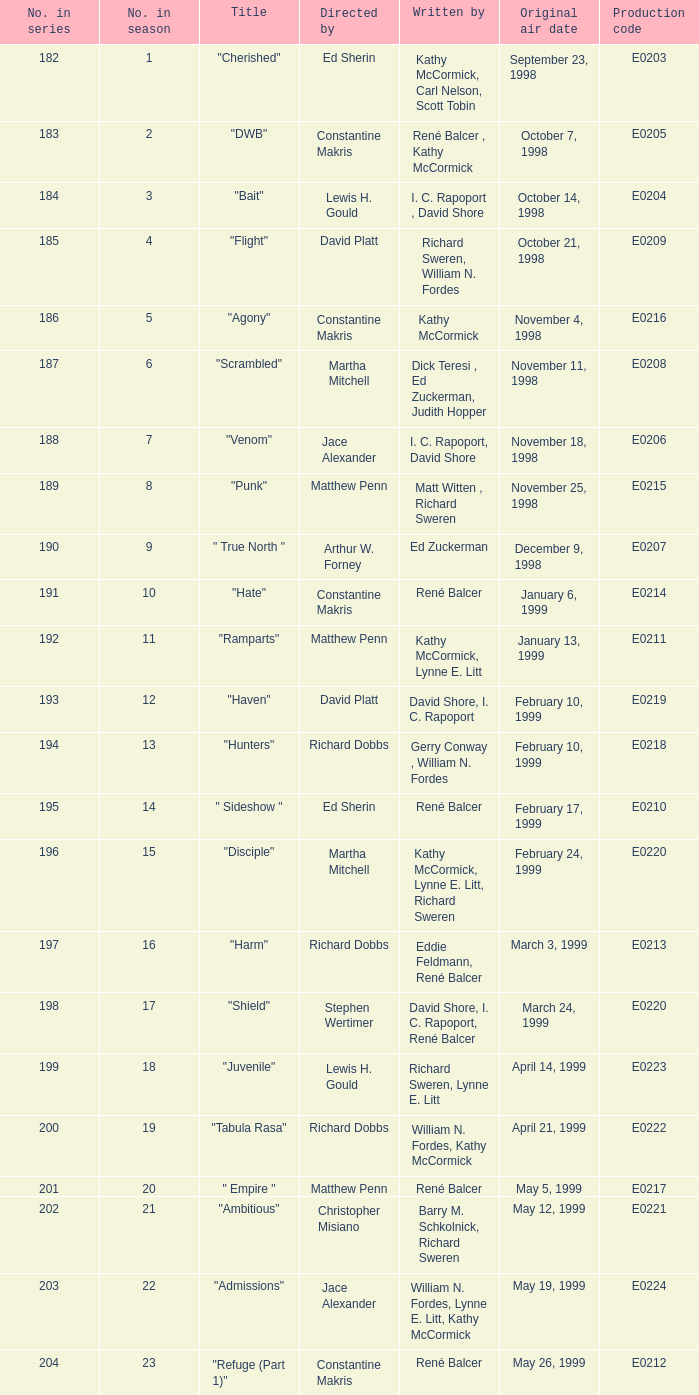The episode with the production code E0208 is directed by who? Martha Mitchell. 